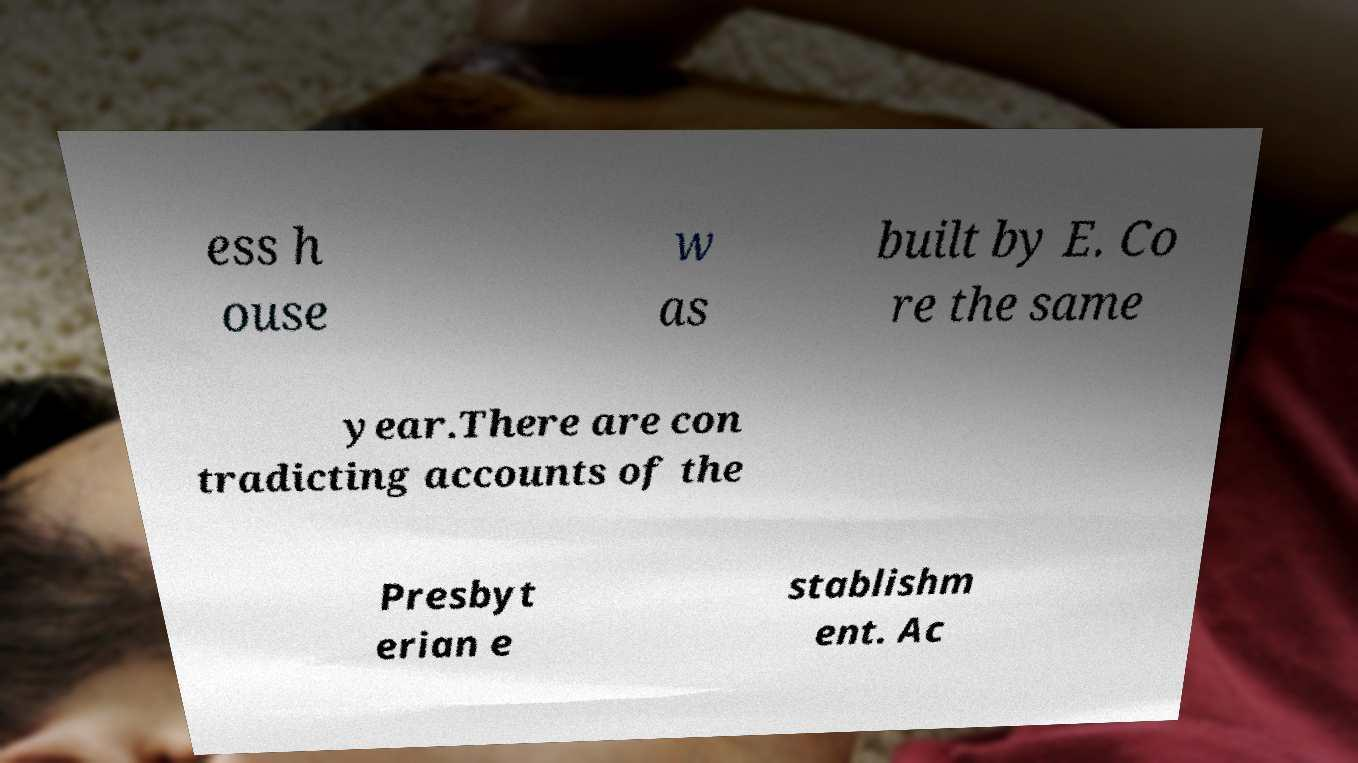Can you read and provide the text displayed in the image?This photo seems to have some interesting text. Can you extract and type it out for me? ess h ouse w as built by E. Co re the same year.There are con tradicting accounts of the Presbyt erian e stablishm ent. Ac 